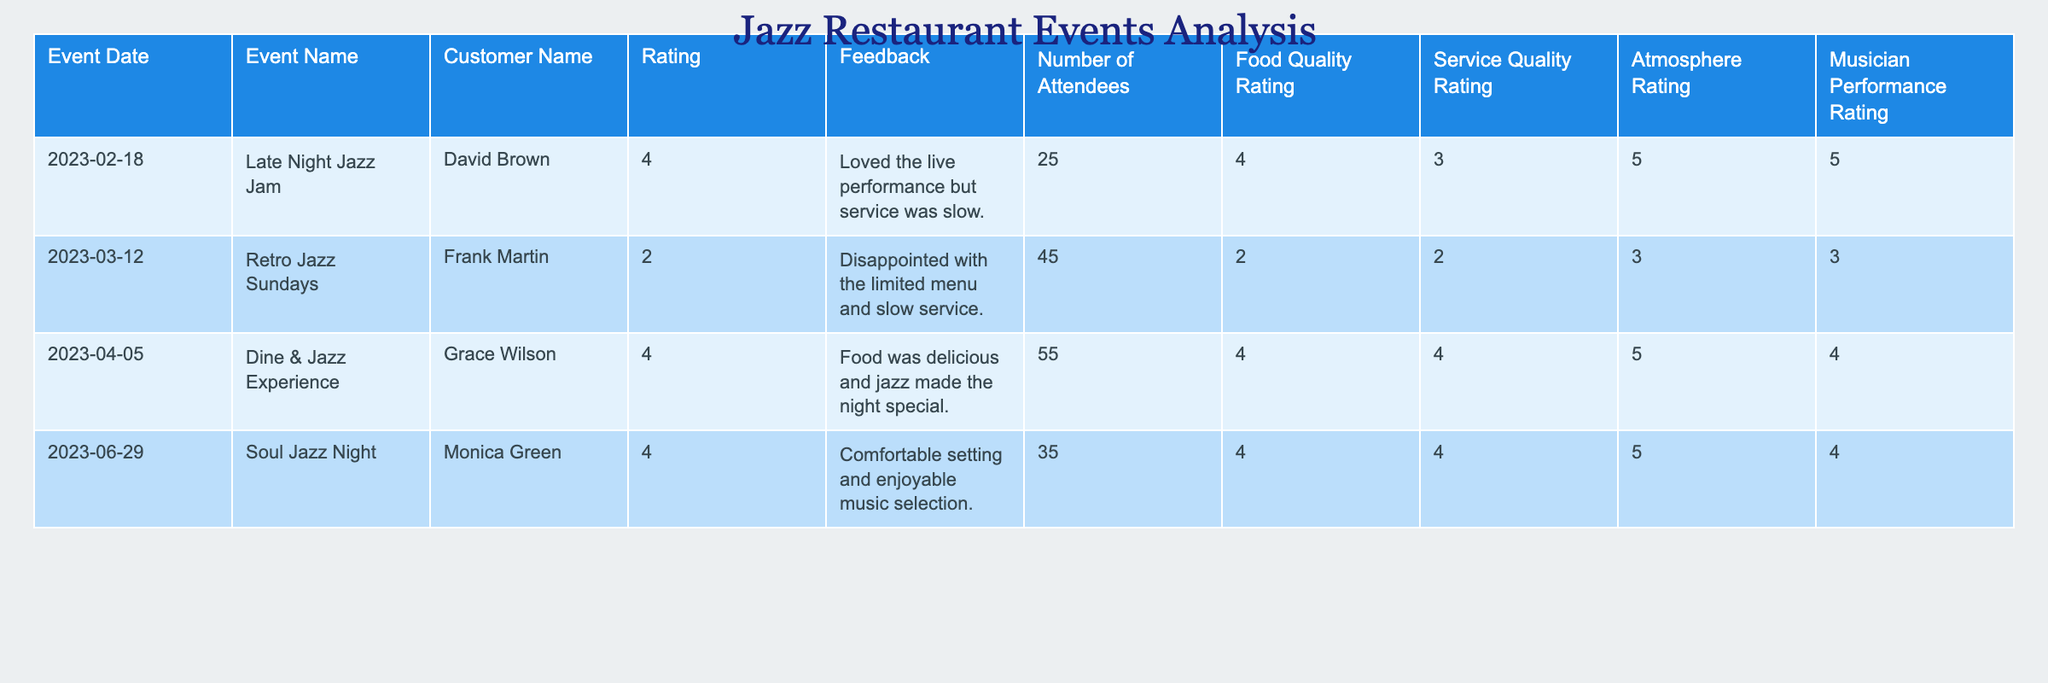What is the highest customer rating given among the events? Review the "Rating" column to identify the maximum value. The ratings listed are 4, 2, 4, and 4, with the highest being 4.
Answer: 4 What was the food quality rating for the "Retro Jazz Sundays" event? Locate the row for "Retro Jazz Sundays" and read the corresponding "Food Quality Rating," which is 2.
Answer: 2 Which event had the lowest service quality rating? Inspect the "Service Quality Rating" column and find the minimum value. The ratings listed are 3, 2, 4, and 4, with the lowest rating being 2 for "Retro Jazz Sundays."
Answer: "Retro Jazz Sundays" What is the average atmosphere rating across all events? Calculate the average by summing the atmosphere ratings 5, 3, 5, and 5 (totaling 18) and dividing by the number of events (4): 18/4 = 4.5.
Answer: 4.5 How many attendees were present at the "Dine & Jazz Experience"? Simply find the number in the "Number of Attendees" column for that event. It shows 55 attendees.
Answer: 55 Did any event receive a customer rating of 5? Inspect the "Rating" column to check for the presence of the number 5. It does not appear, so the answer is no.
Answer: No What was the feedback for the event with 35 attendees? Locate the row with 35 attendees and read the corresponding feedback, which states, "Comfortable setting and enjoyable music selection."
Answer: "Comfortable setting and enjoyable music selection." Which event had the best atmosphere rating and what was it? Review the "Atmosphere Rating" column to identify the maximum value. The best rating of 5 corresponds to the events "Late Night Jazz Jam," "Dine & Jazz Experience," and "Soul Jazz Night."
Answer: "Late Night Jazz Jam," "Dine & Jazz Experience," "Soul Jazz Night" What event had both the lowest food quality rating and the lowest service quality rating? Check the ratings for each event to see that "Retro Jazz Sundays" had the lowest food quality rating of 2 and the lowest service quality rating of 2, fulfilling both conditions.
Answer: "Retro Jazz Sundays" What is the total number of attendees across all events? Sum the number of attendees from each event: 25 + 45 + 55 + 35 = 160.
Answer: 160 